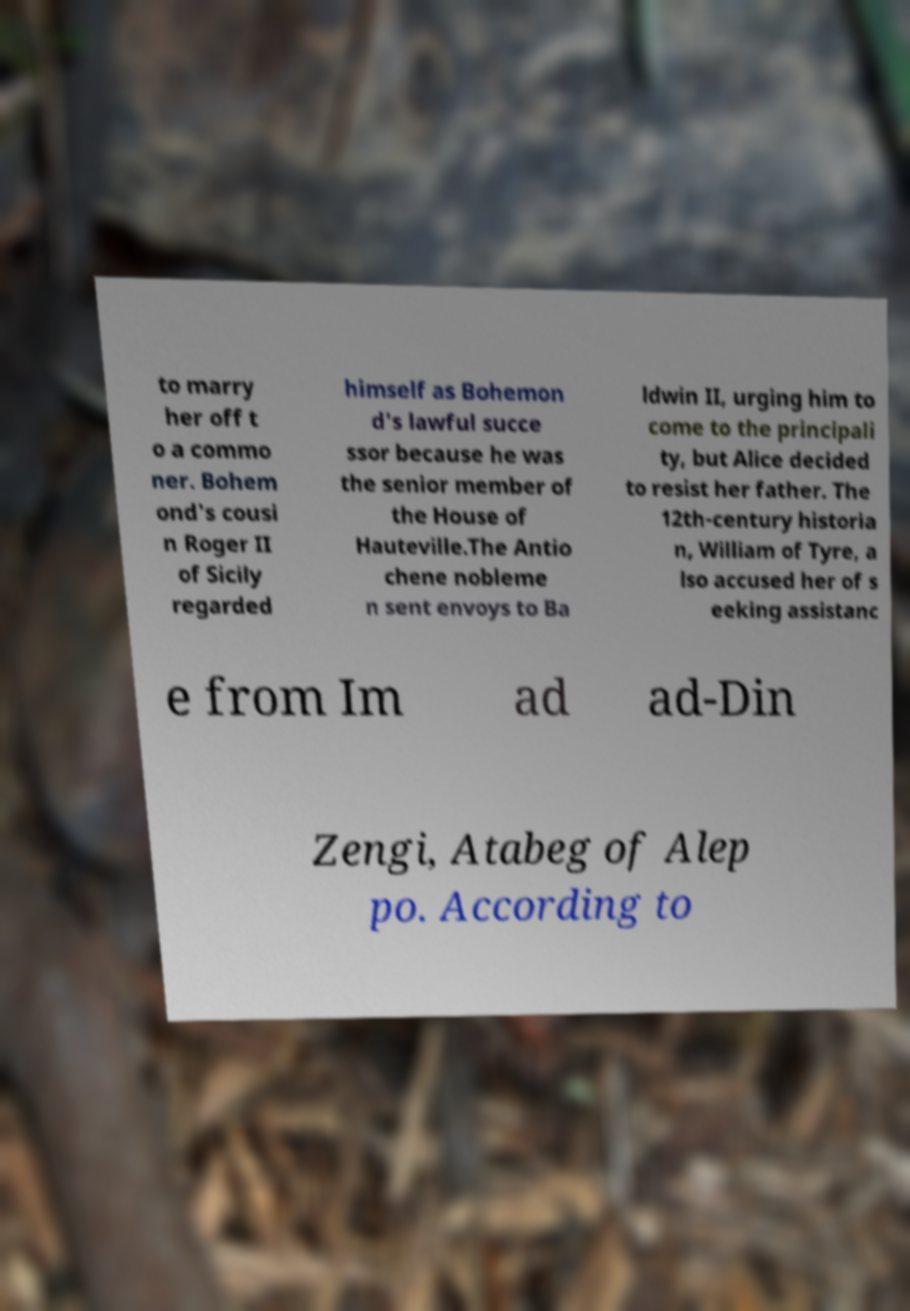Could you assist in decoding the text presented in this image and type it out clearly? to marry her off t o a commo ner. Bohem ond's cousi n Roger II of Sicily regarded himself as Bohemon d's lawful succe ssor because he was the senior member of the House of Hauteville.The Antio chene nobleme n sent envoys to Ba ldwin II, urging him to come to the principali ty, but Alice decided to resist her father. The 12th-century historia n, William of Tyre, a lso accused her of s eeking assistanc e from Im ad ad-Din Zengi, Atabeg of Alep po. According to 